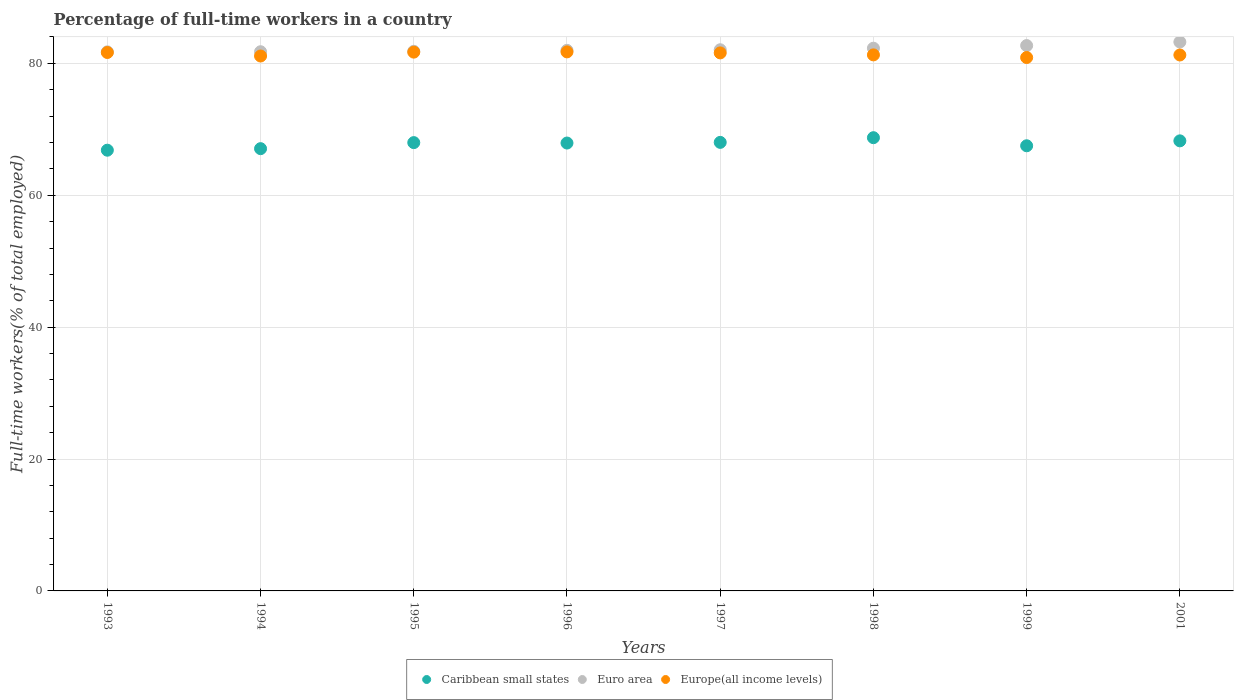What is the percentage of full-time workers in Europe(all income levels) in 2001?
Provide a succinct answer. 81.27. Across all years, what is the maximum percentage of full-time workers in Caribbean small states?
Offer a terse response. 68.73. Across all years, what is the minimum percentage of full-time workers in Europe(all income levels)?
Keep it short and to the point. 80.89. In which year was the percentage of full-time workers in Europe(all income levels) minimum?
Offer a very short reply. 1999. What is the total percentage of full-time workers in Caribbean small states in the graph?
Provide a succinct answer. 542.29. What is the difference between the percentage of full-time workers in Europe(all income levels) in 1996 and that in 2001?
Provide a succinct answer. 0.47. What is the difference between the percentage of full-time workers in Europe(all income levels) in 1998 and the percentage of full-time workers in Caribbean small states in 1994?
Your answer should be very brief. 14.22. What is the average percentage of full-time workers in Euro area per year?
Offer a very short reply. 82.2. In the year 1994, what is the difference between the percentage of full-time workers in Euro area and percentage of full-time workers in Caribbean small states?
Offer a terse response. 14.7. What is the ratio of the percentage of full-time workers in Europe(all income levels) in 1993 to that in 1994?
Make the answer very short. 1.01. Is the percentage of full-time workers in Euro area in 1997 less than that in 2001?
Keep it short and to the point. Yes. What is the difference between the highest and the second highest percentage of full-time workers in Caribbean small states?
Give a very brief answer. 0.48. What is the difference between the highest and the lowest percentage of full-time workers in Europe(all income levels)?
Ensure brevity in your answer.  0.85. In how many years, is the percentage of full-time workers in Euro area greater than the average percentage of full-time workers in Euro area taken over all years?
Your response must be concise. 3. Is it the case that in every year, the sum of the percentage of full-time workers in Caribbean small states and percentage of full-time workers in Euro area  is greater than the percentage of full-time workers in Europe(all income levels)?
Provide a succinct answer. Yes. Is the percentage of full-time workers in Caribbean small states strictly less than the percentage of full-time workers in Europe(all income levels) over the years?
Provide a succinct answer. Yes. How many dotlines are there?
Make the answer very short. 3. How many years are there in the graph?
Give a very brief answer. 8. Where does the legend appear in the graph?
Give a very brief answer. Bottom center. How many legend labels are there?
Ensure brevity in your answer.  3. How are the legend labels stacked?
Offer a very short reply. Horizontal. What is the title of the graph?
Your response must be concise. Percentage of full-time workers in a country. What is the label or title of the Y-axis?
Offer a very short reply. Full-time workers(% of total employed). What is the Full-time workers(% of total employed) of Caribbean small states in 1993?
Your answer should be very brief. 66.83. What is the Full-time workers(% of total employed) in Euro area in 1993?
Make the answer very short. 81.75. What is the Full-time workers(% of total employed) of Europe(all income levels) in 1993?
Provide a succinct answer. 81.65. What is the Full-time workers(% of total employed) in Caribbean small states in 1994?
Provide a succinct answer. 67.06. What is the Full-time workers(% of total employed) in Euro area in 1994?
Your answer should be compact. 81.76. What is the Full-time workers(% of total employed) of Europe(all income levels) in 1994?
Your answer should be compact. 81.12. What is the Full-time workers(% of total employed) of Caribbean small states in 1995?
Keep it short and to the point. 67.98. What is the Full-time workers(% of total employed) of Euro area in 1995?
Ensure brevity in your answer.  81.83. What is the Full-time workers(% of total employed) of Europe(all income levels) in 1995?
Your answer should be compact. 81.7. What is the Full-time workers(% of total employed) in Caribbean small states in 1996?
Give a very brief answer. 67.92. What is the Full-time workers(% of total employed) in Euro area in 1996?
Your answer should be compact. 81.98. What is the Full-time workers(% of total employed) of Europe(all income levels) in 1996?
Provide a succinct answer. 81.74. What is the Full-time workers(% of total employed) of Caribbean small states in 1997?
Your answer should be very brief. 68.02. What is the Full-time workers(% of total employed) in Euro area in 1997?
Offer a very short reply. 82.06. What is the Full-time workers(% of total employed) of Europe(all income levels) in 1997?
Provide a succinct answer. 81.59. What is the Full-time workers(% of total employed) of Caribbean small states in 1998?
Your response must be concise. 68.73. What is the Full-time workers(% of total employed) of Euro area in 1998?
Your answer should be very brief. 82.3. What is the Full-time workers(% of total employed) of Europe(all income levels) in 1998?
Your response must be concise. 81.29. What is the Full-time workers(% of total employed) in Caribbean small states in 1999?
Give a very brief answer. 67.5. What is the Full-time workers(% of total employed) of Euro area in 1999?
Offer a terse response. 82.7. What is the Full-time workers(% of total employed) of Europe(all income levels) in 1999?
Make the answer very short. 80.89. What is the Full-time workers(% of total employed) of Caribbean small states in 2001?
Provide a succinct answer. 68.25. What is the Full-time workers(% of total employed) in Euro area in 2001?
Provide a short and direct response. 83.24. What is the Full-time workers(% of total employed) of Europe(all income levels) in 2001?
Ensure brevity in your answer.  81.27. Across all years, what is the maximum Full-time workers(% of total employed) in Caribbean small states?
Offer a terse response. 68.73. Across all years, what is the maximum Full-time workers(% of total employed) of Euro area?
Your answer should be compact. 83.24. Across all years, what is the maximum Full-time workers(% of total employed) in Europe(all income levels)?
Provide a short and direct response. 81.74. Across all years, what is the minimum Full-time workers(% of total employed) in Caribbean small states?
Your response must be concise. 66.83. Across all years, what is the minimum Full-time workers(% of total employed) of Euro area?
Provide a succinct answer. 81.75. Across all years, what is the minimum Full-time workers(% of total employed) of Europe(all income levels)?
Keep it short and to the point. 80.89. What is the total Full-time workers(% of total employed) of Caribbean small states in the graph?
Keep it short and to the point. 542.29. What is the total Full-time workers(% of total employed) of Euro area in the graph?
Provide a short and direct response. 657.62. What is the total Full-time workers(% of total employed) in Europe(all income levels) in the graph?
Your answer should be compact. 651.23. What is the difference between the Full-time workers(% of total employed) in Caribbean small states in 1993 and that in 1994?
Make the answer very short. -0.23. What is the difference between the Full-time workers(% of total employed) in Euro area in 1993 and that in 1994?
Give a very brief answer. -0.02. What is the difference between the Full-time workers(% of total employed) of Europe(all income levels) in 1993 and that in 1994?
Offer a very short reply. 0.53. What is the difference between the Full-time workers(% of total employed) in Caribbean small states in 1993 and that in 1995?
Offer a very short reply. -1.15. What is the difference between the Full-time workers(% of total employed) of Euro area in 1993 and that in 1995?
Offer a very short reply. -0.08. What is the difference between the Full-time workers(% of total employed) of Europe(all income levels) in 1993 and that in 1995?
Give a very brief answer. -0.06. What is the difference between the Full-time workers(% of total employed) in Caribbean small states in 1993 and that in 1996?
Make the answer very short. -1.09. What is the difference between the Full-time workers(% of total employed) of Euro area in 1993 and that in 1996?
Provide a succinct answer. -0.23. What is the difference between the Full-time workers(% of total employed) in Europe(all income levels) in 1993 and that in 1996?
Make the answer very short. -0.09. What is the difference between the Full-time workers(% of total employed) in Caribbean small states in 1993 and that in 1997?
Provide a short and direct response. -1.19. What is the difference between the Full-time workers(% of total employed) of Euro area in 1993 and that in 1997?
Ensure brevity in your answer.  -0.32. What is the difference between the Full-time workers(% of total employed) of Europe(all income levels) in 1993 and that in 1997?
Your answer should be compact. 0.06. What is the difference between the Full-time workers(% of total employed) in Caribbean small states in 1993 and that in 1998?
Provide a short and direct response. -1.9. What is the difference between the Full-time workers(% of total employed) of Euro area in 1993 and that in 1998?
Offer a terse response. -0.55. What is the difference between the Full-time workers(% of total employed) in Europe(all income levels) in 1993 and that in 1998?
Your response must be concise. 0.36. What is the difference between the Full-time workers(% of total employed) in Caribbean small states in 1993 and that in 1999?
Give a very brief answer. -0.67. What is the difference between the Full-time workers(% of total employed) of Euro area in 1993 and that in 1999?
Offer a terse response. -0.95. What is the difference between the Full-time workers(% of total employed) of Europe(all income levels) in 1993 and that in 1999?
Your answer should be compact. 0.76. What is the difference between the Full-time workers(% of total employed) of Caribbean small states in 1993 and that in 2001?
Offer a terse response. -1.42. What is the difference between the Full-time workers(% of total employed) in Euro area in 1993 and that in 2001?
Your response must be concise. -1.49. What is the difference between the Full-time workers(% of total employed) of Europe(all income levels) in 1993 and that in 2001?
Make the answer very short. 0.37. What is the difference between the Full-time workers(% of total employed) in Caribbean small states in 1994 and that in 1995?
Your answer should be compact. -0.92. What is the difference between the Full-time workers(% of total employed) in Euro area in 1994 and that in 1995?
Provide a succinct answer. -0.07. What is the difference between the Full-time workers(% of total employed) in Europe(all income levels) in 1994 and that in 1995?
Make the answer very short. -0.59. What is the difference between the Full-time workers(% of total employed) of Caribbean small states in 1994 and that in 1996?
Your answer should be very brief. -0.85. What is the difference between the Full-time workers(% of total employed) in Euro area in 1994 and that in 1996?
Make the answer very short. -0.21. What is the difference between the Full-time workers(% of total employed) in Europe(all income levels) in 1994 and that in 1996?
Your response must be concise. -0.62. What is the difference between the Full-time workers(% of total employed) of Caribbean small states in 1994 and that in 1997?
Ensure brevity in your answer.  -0.95. What is the difference between the Full-time workers(% of total employed) in Euro area in 1994 and that in 1997?
Ensure brevity in your answer.  -0.3. What is the difference between the Full-time workers(% of total employed) in Europe(all income levels) in 1994 and that in 1997?
Give a very brief answer. -0.47. What is the difference between the Full-time workers(% of total employed) of Caribbean small states in 1994 and that in 1998?
Your answer should be very brief. -1.66. What is the difference between the Full-time workers(% of total employed) in Euro area in 1994 and that in 1998?
Your answer should be very brief. -0.54. What is the difference between the Full-time workers(% of total employed) of Europe(all income levels) in 1994 and that in 1998?
Provide a short and direct response. -0.17. What is the difference between the Full-time workers(% of total employed) in Caribbean small states in 1994 and that in 1999?
Offer a terse response. -0.44. What is the difference between the Full-time workers(% of total employed) in Euro area in 1994 and that in 1999?
Offer a terse response. -0.94. What is the difference between the Full-time workers(% of total employed) in Europe(all income levels) in 1994 and that in 1999?
Your answer should be very brief. 0.23. What is the difference between the Full-time workers(% of total employed) in Caribbean small states in 1994 and that in 2001?
Offer a very short reply. -1.18. What is the difference between the Full-time workers(% of total employed) in Euro area in 1994 and that in 2001?
Offer a very short reply. -1.48. What is the difference between the Full-time workers(% of total employed) of Europe(all income levels) in 1994 and that in 2001?
Offer a terse response. -0.16. What is the difference between the Full-time workers(% of total employed) in Caribbean small states in 1995 and that in 1996?
Offer a very short reply. 0.06. What is the difference between the Full-time workers(% of total employed) in Euro area in 1995 and that in 1996?
Give a very brief answer. -0.14. What is the difference between the Full-time workers(% of total employed) in Europe(all income levels) in 1995 and that in 1996?
Your answer should be compact. -0.04. What is the difference between the Full-time workers(% of total employed) in Caribbean small states in 1995 and that in 1997?
Provide a succinct answer. -0.04. What is the difference between the Full-time workers(% of total employed) of Euro area in 1995 and that in 1997?
Ensure brevity in your answer.  -0.23. What is the difference between the Full-time workers(% of total employed) of Europe(all income levels) in 1995 and that in 1997?
Provide a succinct answer. 0.11. What is the difference between the Full-time workers(% of total employed) of Caribbean small states in 1995 and that in 1998?
Make the answer very short. -0.75. What is the difference between the Full-time workers(% of total employed) in Euro area in 1995 and that in 1998?
Your answer should be very brief. -0.47. What is the difference between the Full-time workers(% of total employed) of Europe(all income levels) in 1995 and that in 1998?
Your answer should be very brief. 0.42. What is the difference between the Full-time workers(% of total employed) in Caribbean small states in 1995 and that in 1999?
Provide a succinct answer. 0.48. What is the difference between the Full-time workers(% of total employed) of Euro area in 1995 and that in 1999?
Ensure brevity in your answer.  -0.87. What is the difference between the Full-time workers(% of total employed) in Europe(all income levels) in 1995 and that in 1999?
Your answer should be compact. 0.82. What is the difference between the Full-time workers(% of total employed) in Caribbean small states in 1995 and that in 2001?
Ensure brevity in your answer.  -0.27. What is the difference between the Full-time workers(% of total employed) in Euro area in 1995 and that in 2001?
Provide a short and direct response. -1.41. What is the difference between the Full-time workers(% of total employed) of Europe(all income levels) in 1995 and that in 2001?
Offer a very short reply. 0.43. What is the difference between the Full-time workers(% of total employed) of Caribbean small states in 1996 and that in 1997?
Offer a terse response. -0.1. What is the difference between the Full-time workers(% of total employed) of Euro area in 1996 and that in 1997?
Offer a terse response. -0.09. What is the difference between the Full-time workers(% of total employed) of Europe(all income levels) in 1996 and that in 1997?
Ensure brevity in your answer.  0.15. What is the difference between the Full-time workers(% of total employed) in Caribbean small states in 1996 and that in 1998?
Your answer should be very brief. -0.81. What is the difference between the Full-time workers(% of total employed) of Euro area in 1996 and that in 1998?
Your answer should be very brief. -0.32. What is the difference between the Full-time workers(% of total employed) in Europe(all income levels) in 1996 and that in 1998?
Provide a short and direct response. 0.45. What is the difference between the Full-time workers(% of total employed) in Caribbean small states in 1996 and that in 1999?
Make the answer very short. 0.41. What is the difference between the Full-time workers(% of total employed) in Euro area in 1996 and that in 1999?
Keep it short and to the point. -0.72. What is the difference between the Full-time workers(% of total employed) in Europe(all income levels) in 1996 and that in 1999?
Keep it short and to the point. 0.85. What is the difference between the Full-time workers(% of total employed) in Caribbean small states in 1996 and that in 2001?
Your answer should be compact. -0.33. What is the difference between the Full-time workers(% of total employed) in Euro area in 1996 and that in 2001?
Offer a very short reply. -1.27. What is the difference between the Full-time workers(% of total employed) of Europe(all income levels) in 1996 and that in 2001?
Provide a succinct answer. 0.47. What is the difference between the Full-time workers(% of total employed) in Caribbean small states in 1997 and that in 1998?
Your answer should be compact. -0.71. What is the difference between the Full-time workers(% of total employed) in Euro area in 1997 and that in 1998?
Provide a short and direct response. -0.23. What is the difference between the Full-time workers(% of total employed) of Europe(all income levels) in 1997 and that in 1998?
Your answer should be very brief. 0.3. What is the difference between the Full-time workers(% of total employed) in Caribbean small states in 1997 and that in 1999?
Your response must be concise. 0.52. What is the difference between the Full-time workers(% of total employed) in Euro area in 1997 and that in 1999?
Your response must be concise. -0.63. What is the difference between the Full-time workers(% of total employed) in Europe(all income levels) in 1997 and that in 1999?
Provide a short and direct response. 0.7. What is the difference between the Full-time workers(% of total employed) in Caribbean small states in 1997 and that in 2001?
Provide a succinct answer. -0.23. What is the difference between the Full-time workers(% of total employed) in Euro area in 1997 and that in 2001?
Your response must be concise. -1.18. What is the difference between the Full-time workers(% of total employed) of Europe(all income levels) in 1997 and that in 2001?
Make the answer very short. 0.31. What is the difference between the Full-time workers(% of total employed) in Caribbean small states in 1998 and that in 1999?
Provide a short and direct response. 1.23. What is the difference between the Full-time workers(% of total employed) in Euro area in 1998 and that in 1999?
Your answer should be compact. -0.4. What is the difference between the Full-time workers(% of total employed) of Europe(all income levels) in 1998 and that in 1999?
Provide a succinct answer. 0.4. What is the difference between the Full-time workers(% of total employed) of Caribbean small states in 1998 and that in 2001?
Your answer should be very brief. 0.48. What is the difference between the Full-time workers(% of total employed) of Euro area in 1998 and that in 2001?
Keep it short and to the point. -0.94. What is the difference between the Full-time workers(% of total employed) of Europe(all income levels) in 1998 and that in 2001?
Keep it short and to the point. 0.01. What is the difference between the Full-time workers(% of total employed) in Caribbean small states in 1999 and that in 2001?
Offer a terse response. -0.75. What is the difference between the Full-time workers(% of total employed) of Euro area in 1999 and that in 2001?
Your answer should be compact. -0.54. What is the difference between the Full-time workers(% of total employed) in Europe(all income levels) in 1999 and that in 2001?
Provide a short and direct response. -0.39. What is the difference between the Full-time workers(% of total employed) in Caribbean small states in 1993 and the Full-time workers(% of total employed) in Euro area in 1994?
Offer a very short reply. -14.93. What is the difference between the Full-time workers(% of total employed) of Caribbean small states in 1993 and the Full-time workers(% of total employed) of Europe(all income levels) in 1994?
Provide a succinct answer. -14.28. What is the difference between the Full-time workers(% of total employed) in Euro area in 1993 and the Full-time workers(% of total employed) in Europe(all income levels) in 1994?
Provide a short and direct response. 0.63. What is the difference between the Full-time workers(% of total employed) of Caribbean small states in 1993 and the Full-time workers(% of total employed) of Euro area in 1995?
Give a very brief answer. -15. What is the difference between the Full-time workers(% of total employed) in Caribbean small states in 1993 and the Full-time workers(% of total employed) in Europe(all income levels) in 1995?
Ensure brevity in your answer.  -14.87. What is the difference between the Full-time workers(% of total employed) of Euro area in 1993 and the Full-time workers(% of total employed) of Europe(all income levels) in 1995?
Your answer should be very brief. 0.05. What is the difference between the Full-time workers(% of total employed) of Caribbean small states in 1993 and the Full-time workers(% of total employed) of Euro area in 1996?
Your response must be concise. -15.14. What is the difference between the Full-time workers(% of total employed) in Caribbean small states in 1993 and the Full-time workers(% of total employed) in Europe(all income levels) in 1996?
Ensure brevity in your answer.  -14.91. What is the difference between the Full-time workers(% of total employed) in Euro area in 1993 and the Full-time workers(% of total employed) in Europe(all income levels) in 1996?
Keep it short and to the point. 0.01. What is the difference between the Full-time workers(% of total employed) in Caribbean small states in 1993 and the Full-time workers(% of total employed) in Euro area in 1997?
Offer a very short reply. -15.23. What is the difference between the Full-time workers(% of total employed) of Caribbean small states in 1993 and the Full-time workers(% of total employed) of Europe(all income levels) in 1997?
Give a very brief answer. -14.76. What is the difference between the Full-time workers(% of total employed) in Euro area in 1993 and the Full-time workers(% of total employed) in Europe(all income levels) in 1997?
Give a very brief answer. 0.16. What is the difference between the Full-time workers(% of total employed) of Caribbean small states in 1993 and the Full-time workers(% of total employed) of Euro area in 1998?
Your answer should be compact. -15.47. What is the difference between the Full-time workers(% of total employed) in Caribbean small states in 1993 and the Full-time workers(% of total employed) in Europe(all income levels) in 1998?
Your response must be concise. -14.45. What is the difference between the Full-time workers(% of total employed) in Euro area in 1993 and the Full-time workers(% of total employed) in Europe(all income levels) in 1998?
Offer a terse response. 0.46. What is the difference between the Full-time workers(% of total employed) of Caribbean small states in 1993 and the Full-time workers(% of total employed) of Euro area in 1999?
Make the answer very short. -15.87. What is the difference between the Full-time workers(% of total employed) in Caribbean small states in 1993 and the Full-time workers(% of total employed) in Europe(all income levels) in 1999?
Offer a terse response. -14.05. What is the difference between the Full-time workers(% of total employed) in Euro area in 1993 and the Full-time workers(% of total employed) in Europe(all income levels) in 1999?
Keep it short and to the point. 0.86. What is the difference between the Full-time workers(% of total employed) of Caribbean small states in 1993 and the Full-time workers(% of total employed) of Euro area in 2001?
Give a very brief answer. -16.41. What is the difference between the Full-time workers(% of total employed) in Caribbean small states in 1993 and the Full-time workers(% of total employed) in Europe(all income levels) in 2001?
Your response must be concise. -14.44. What is the difference between the Full-time workers(% of total employed) of Euro area in 1993 and the Full-time workers(% of total employed) of Europe(all income levels) in 2001?
Give a very brief answer. 0.47. What is the difference between the Full-time workers(% of total employed) of Caribbean small states in 1994 and the Full-time workers(% of total employed) of Euro area in 1995?
Keep it short and to the point. -14.77. What is the difference between the Full-time workers(% of total employed) in Caribbean small states in 1994 and the Full-time workers(% of total employed) in Europe(all income levels) in 1995?
Offer a terse response. -14.64. What is the difference between the Full-time workers(% of total employed) in Euro area in 1994 and the Full-time workers(% of total employed) in Europe(all income levels) in 1995?
Provide a succinct answer. 0.06. What is the difference between the Full-time workers(% of total employed) of Caribbean small states in 1994 and the Full-time workers(% of total employed) of Euro area in 1996?
Provide a short and direct response. -14.91. What is the difference between the Full-time workers(% of total employed) of Caribbean small states in 1994 and the Full-time workers(% of total employed) of Europe(all income levels) in 1996?
Offer a terse response. -14.67. What is the difference between the Full-time workers(% of total employed) in Euro area in 1994 and the Full-time workers(% of total employed) in Europe(all income levels) in 1996?
Keep it short and to the point. 0.02. What is the difference between the Full-time workers(% of total employed) of Caribbean small states in 1994 and the Full-time workers(% of total employed) of Euro area in 1997?
Offer a terse response. -15. What is the difference between the Full-time workers(% of total employed) in Caribbean small states in 1994 and the Full-time workers(% of total employed) in Europe(all income levels) in 1997?
Give a very brief answer. -14.52. What is the difference between the Full-time workers(% of total employed) of Euro area in 1994 and the Full-time workers(% of total employed) of Europe(all income levels) in 1997?
Provide a succinct answer. 0.18. What is the difference between the Full-time workers(% of total employed) of Caribbean small states in 1994 and the Full-time workers(% of total employed) of Euro area in 1998?
Provide a short and direct response. -15.23. What is the difference between the Full-time workers(% of total employed) of Caribbean small states in 1994 and the Full-time workers(% of total employed) of Europe(all income levels) in 1998?
Your response must be concise. -14.22. What is the difference between the Full-time workers(% of total employed) of Euro area in 1994 and the Full-time workers(% of total employed) of Europe(all income levels) in 1998?
Keep it short and to the point. 0.48. What is the difference between the Full-time workers(% of total employed) in Caribbean small states in 1994 and the Full-time workers(% of total employed) in Euro area in 1999?
Your response must be concise. -15.63. What is the difference between the Full-time workers(% of total employed) of Caribbean small states in 1994 and the Full-time workers(% of total employed) of Europe(all income levels) in 1999?
Provide a short and direct response. -13.82. What is the difference between the Full-time workers(% of total employed) of Euro area in 1994 and the Full-time workers(% of total employed) of Europe(all income levels) in 1999?
Ensure brevity in your answer.  0.88. What is the difference between the Full-time workers(% of total employed) of Caribbean small states in 1994 and the Full-time workers(% of total employed) of Euro area in 2001?
Provide a succinct answer. -16.18. What is the difference between the Full-time workers(% of total employed) in Caribbean small states in 1994 and the Full-time workers(% of total employed) in Europe(all income levels) in 2001?
Offer a very short reply. -14.21. What is the difference between the Full-time workers(% of total employed) of Euro area in 1994 and the Full-time workers(% of total employed) of Europe(all income levels) in 2001?
Offer a terse response. 0.49. What is the difference between the Full-time workers(% of total employed) in Caribbean small states in 1995 and the Full-time workers(% of total employed) in Euro area in 1996?
Give a very brief answer. -13.99. What is the difference between the Full-time workers(% of total employed) in Caribbean small states in 1995 and the Full-time workers(% of total employed) in Europe(all income levels) in 1996?
Make the answer very short. -13.76. What is the difference between the Full-time workers(% of total employed) in Euro area in 1995 and the Full-time workers(% of total employed) in Europe(all income levels) in 1996?
Your response must be concise. 0.09. What is the difference between the Full-time workers(% of total employed) of Caribbean small states in 1995 and the Full-time workers(% of total employed) of Euro area in 1997?
Ensure brevity in your answer.  -14.08. What is the difference between the Full-time workers(% of total employed) in Caribbean small states in 1995 and the Full-time workers(% of total employed) in Europe(all income levels) in 1997?
Provide a short and direct response. -13.61. What is the difference between the Full-time workers(% of total employed) of Euro area in 1995 and the Full-time workers(% of total employed) of Europe(all income levels) in 1997?
Give a very brief answer. 0.24. What is the difference between the Full-time workers(% of total employed) of Caribbean small states in 1995 and the Full-time workers(% of total employed) of Euro area in 1998?
Provide a succinct answer. -14.32. What is the difference between the Full-time workers(% of total employed) in Caribbean small states in 1995 and the Full-time workers(% of total employed) in Europe(all income levels) in 1998?
Offer a terse response. -13.3. What is the difference between the Full-time workers(% of total employed) in Euro area in 1995 and the Full-time workers(% of total employed) in Europe(all income levels) in 1998?
Your response must be concise. 0.55. What is the difference between the Full-time workers(% of total employed) of Caribbean small states in 1995 and the Full-time workers(% of total employed) of Euro area in 1999?
Your response must be concise. -14.72. What is the difference between the Full-time workers(% of total employed) of Caribbean small states in 1995 and the Full-time workers(% of total employed) of Europe(all income levels) in 1999?
Ensure brevity in your answer.  -12.9. What is the difference between the Full-time workers(% of total employed) in Euro area in 1995 and the Full-time workers(% of total employed) in Europe(all income levels) in 1999?
Make the answer very short. 0.94. What is the difference between the Full-time workers(% of total employed) of Caribbean small states in 1995 and the Full-time workers(% of total employed) of Euro area in 2001?
Give a very brief answer. -15.26. What is the difference between the Full-time workers(% of total employed) in Caribbean small states in 1995 and the Full-time workers(% of total employed) in Europe(all income levels) in 2001?
Ensure brevity in your answer.  -13.29. What is the difference between the Full-time workers(% of total employed) in Euro area in 1995 and the Full-time workers(% of total employed) in Europe(all income levels) in 2001?
Provide a short and direct response. 0.56. What is the difference between the Full-time workers(% of total employed) in Caribbean small states in 1996 and the Full-time workers(% of total employed) in Euro area in 1997?
Offer a terse response. -14.15. What is the difference between the Full-time workers(% of total employed) in Caribbean small states in 1996 and the Full-time workers(% of total employed) in Europe(all income levels) in 1997?
Your answer should be compact. -13.67. What is the difference between the Full-time workers(% of total employed) of Euro area in 1996 and the Full-time workers(% of total employed) of Europe(all income levels) in 1997?
Ensure brevity in your answer.  0.39. What is the difference between the Full-time workers(% of total employed) in Caribbean small states in 1996 and the Full-time workers(% of total employed) in Euro area in 1998?
Ensure brevity in your answer.  -14.38. What is the difference between the Full-time workers(% of total employed) in Caribbean small states in 1996 and the Full-time workers(% of total employed) in Europe(all income levels) in 1998?
Your answer should be compact. -13.37. What is the difference between the Full-time workers(% of total employed) in Euro area in 1996 and the Full-time workers(% of total employed) in Europe(all income levels) in 1998?
Offer a terse response. 0.69. What is the difference between the Full-time workers(% of total employed) in Caribbean small states in 1996 and the Full-time workers(% of total employed) in Euro area in 1999?
Keep it short and to the point. -14.78. What is the difference between the Full-time workers(% of total employed) in Caribbean small states in 1996 and the Full-time workers(% of total employed) in Europe(all income levels) in 1999?
Provide a short and direct response. -12.97. What is the difference between the Full-time workers(% of total employed) of Euro area in 1996 and the Full-time workers(% of total employed) of Europe(all income levels) in 1999?
Make the answer very short. 1.09. What is the difference between the Full-time workers(% of total employed) in Caribbean small states in 1996 and the Full-time workers(% of total employed) in Euro area in 2001?
Your answer should be very brief. -15.32. What is the difference between the Full-time workers(% of total employed) of Caribbean small states in 1996 and the Full-time workers(% of total employed) of Europe(all income levels) in 2001?
Offer a terse response. -13.35. What is the difference between the Full-time workers(% of total employed) in Euro area in 1996 and the Full-time workers(% of total employed) in Europe(all income levels) in 2001?
Your answer should be very brief. 0.7. What is the difference between the Full-time workers(% of total employed) of Caribbean small states in 1997 and the Full-time workers(% of total employed) of Euro area in 1998?
Your answer should be compact. -14.28. What is the difference between the Full-time workers(% of total employed) in Caribbean small states in 1997 and the Full-time workers(% of total employed) in Europe(all income levels) in 1998?
Provide a succinct answer. -13.27. What is the difference between the Full-time workers(% of total employed) of Euro area in 1997 and the Full-time workers(% of total employed) of Europe(all income levels) in 1998?
Your answer should be compact. 0.78. What is the difference between the Full-time workers(% of total employed) of Caribbean small states in 1997 and the Full-time workers(% of total employed) of Euro area in 1999?
Your answer should be very brief. -14.68. What is the difference between the Full-time workers(% of total employed) of Caribbean small states in 1997 and the Full-time workers(% of total employed) of Europe(all income levels) in 1999?
Make the answer very short. -12.87. What is the difference between the Full-time workers(% of total employed) in Euro area in 1997 and the Full-time workers(% of total employed) in Europe(all income levels) in 1999?
Keep it short and to the point. 1.18. What is the difference between the Full-time workers(% of total employed) of Caribbean small states in 1997 and the Full-time workers(% of total employed) of Euro area in 2001?
Your response must be concise. -15.22. What is the difference between the Full-time workers(% of total employed) of Caribbean small states in 1997 and the Full-time workers(% of total employed) of Europe(all income levels) in 2001?
Provide a short and direct response. -13.25. What is the difference between the Full-time workers(% of total employed) in Euro area in 1997 and the Full-time workers(% of total employed) in Europe(all income levels) in 2001?
Your response must be concise. 0.79. What is the difference between the Full-time workers(% of total employed) in Caribbean small states in 1998 and the Full-time workers(% of total employed) in Euro area in 1999?
Provide a succinct answer. -13.97. What is the difference between the Full-time workers(% of total employed) in Caribbean small states in 1998 and the Full-time workers(% of total employed) in Europe(all income levels) in 1999?
Provide a short and direct response. -12.16. What is the difference between the Full-time workers(% of total employed) in Euro area in 1998 and the Full-time workers(% of total employed) in Europe(all income levels) in 1999?
Offer a very short reply. 1.41. What is the difference between the Full-time workers(% of total employed) in Caribbean small states in 1998 and the Full-time workers(% of total employed) in Euro area in 2001?
Offer a very short reply. -14.51. What is the difference between the Full-time workers(% of total employed) of Caribbean small states in 1998 and the Full-time workers(% of total employed) of Europe(all income levels) in 2001?
Offer a terse response. -12.54. What is the difference between the Full-time workers(% of total employed) in Euro area in 1998 and the Full-time workers(% of total employed) in Europe(all income levels) in 2001?
Make the answer very short. 1.03. What is the difference between the Full-time workers(% of total employed) of Caribbean small states in 1999 and the Full-time workers(% of total employed) of Euro area in 2001?
Offer a very short reply. -15.74. What is the difference between the Full-time workers(% of total employed) in Caribbean small states in 1999 and the Full-time workers(% of total employed) in Europe(all income levels) in 2001?
Your answer should be compact. -13.77. What is the difference between the Full-time workers(% of total employed) in Euro area in 1999 and the Full-time workers(% of total employed) in Europe(all income levels) in 2001?
Your answer should be very brief. 1.43. What is the average Full-time workers(% of total employed) in Caribbean small states per year?
Give a very brief answer. 67.79. What is the average Full-time workers(% of total employed) in Euro area per year?
Your response must be concise. 82.2. What is the average Full-time workers(% of total employed) of Europe(all income levels) per year?
Ensure brevity in your answer.  81.4. In the year 1993, what is the difference between the Full-time workers(% of total employed) in Caribbean small states and Full-time workers(% of total employed) in Euro area?
Provide a short and direct response. -14.91. In the year 1993, what is the difference between the Full-time workers(% of total employed) in Caribbean small states and Full-time workers(% of total employed) in Europe(all income levels)?
Provide a succinct answer. -14.81. In the year 1993, what is the difference between the Full-time workers(% of total employed) of Euro area and Full-time workers(% of total employed) of Europe(all income levels)?
Offer a very short reply. 0.1. In the year 1994, what is the difference between the Full-time workers(% of total employed) of Caribbean small states and Full-time workers(% of total employed) of Euro area?
Your answer should be compact. -14.7. In the year 1994, what is the difference between the Full-time workers(% of total employed) of Caribbean small states and Full-time workers(% of total employed) of Europe(all income levels)?
Provide a short and direct response. -14.05. In the year 1994, what is the difference between the Full-time workers(% of total employed) in Euro area and Full-time workers(% of total employed) in Europe(all income levels)?
Your answer should be compact. 0.65. In the year 1995, what is the difference between the Full-time workers(% of total employed) of Caribbean small states and Full-time workers(% of total employed) of Euro area?
Give a very brief answer. -13.85. In the year 1995, what is the difference between the Full-time workers(% of total employed) in Caribbean small states and Full-time workers(% of total employed) in Europe(all income levels)?
Provide a succinct answer. -13.72. In the year 1995, what is the difference between the Full-time workers(% of total employed) in Euro area and Full-time workers(% of total employed) in Europe(all income levels)?
Make the answer very short. 0.13. In the year 1996, what is the difference between the Full-time workers(% of total employed) in Caribbean small states and Full-time workers(% of total employed) in Euro area?
Make the answer very short. -14.06. In the year 1996, what is the difference between the Full-time workers(% of total employed) in Caribbean small states and Full-time workers(% of total employed) in Europe(all income levels)?
Keep it short and to the point. -13.82. In the year 1996, what is the difference between the Full-time workers(% of total employed) of Euro area and Full-time workers(% of total employed) of Europe(all income levels)?
Your answer should be compact. 0.24. In the year 1997, what is the difference between the Full-time workers(% of total employed) of Caribbean small states and Full-time workers(% of total employed) of Euro area?
Keep it short and to the point. -14.05. In the year 1997, what is the difference between the Full-time workers(% of total employed) in Caribbean small states and Full-time workers(% of total employed) in Europe(all income levels)?
Make the answer very short. -13.57. In the year 1997, what is the difference between the Full-time workers(% of total employed) of Euro area and Full-time workers(% of total employed) of Europe(all income levels)?
Provide a short and direct response. 0.48. In the year 1998, what is the difference between the Full-time workers(% of total employed) of Caribbean small states and Full-time workers(% of total employed) of Euro area?
Your answer should be very brief. -13.57. In the year 1998, what is the difference between the Full-time workers(% of total employed) of Caribbean small states and Full-time workers(% of total employed) of Europe(all income levels)?
Keep it short and to the point. -12.56. In the year 1998, what is the difference between the Full-time workers(% of total employed) in Euro area and Full-time workers(% of total employed) in Europe(all income levels)?
Your response must be concise. 1.01. In the year 1999, what is the difference between the Full-time workers(% of total employed) of Caribbean small states and Full-time workers(% of total employed) of Euro area?
Give a very brief answer. -15.2. In the year 1999, what is the difference between the Full-time workers(% of total employed) in Caribbean small states and Full-time workers(% of total employed) in Europe(all income levels)?
Ensure brevity in your answer.  -13.38. In the year 1999, what is the difference between the Full-time workers(% of total employed) in Euro area and Full-time workers(% of total employed) in Europe(all income levels)?
Your answer should be compact. 1.81. In the year 2001, what is the difference between the Full-time workers(% of total employed) in Caribbean small states and Full-time workers(% of total employed) in Euro area?
Your answer should be compact. -14.99. In the year 2001, what is the difference between the Full-time workers(% of total employed) in Caribbean small states and Full-time workers(% of total employed) in Europe(all income levels)?
Your answer should be very brief. -13.02. In the year 2001, what is the difference between the Full-time workers(% of total employed) of Euro area and Full-time workers(% of total employed) of Europe(all income levels)?
Your response must be concise. 1.97. What is the ratio of the Full-time workers(% of total employed) of Caribbean small states in 1993 to that in 1994?
Provide a succinct answer. 1. What is the ratio of the Full-time workers(% of total employed) in Europe(all income levels) in 1993 to that in 1994?
Make the answer very short. 1.01. What is the ratio of the Full-time workers(% of total employed) of Caribbean small states in 1993 to that in 1995?
Give a very brief answer. 0.98. What is the ratio of the Full-time workers(% of total employed) of Euro area in 1993 to that in 1996?
Your answer should be compact. 1. What is the ratio of the Full-time workers(% of total employed) in Europe(all income levels) in 1993 to that in 1996?
Provide a short and direct response. 1. What is the ratio of the Full-time workers(% of total employed) in Caribbean small states in 1993 to that in 1997?
Offer a very short reply. 0.98. What is the ratio of the Full-time workers(% of total employed) in Caribbean small states in 1993 to that in 1998?
Your answer should be compact. 0.97. What is the ratio of the Full-time workers(% of total employed) of Europe(all income levels) in 1993 to that in 1999?
Keep it short and to the point. 1.01. What is the ratio of the Full-time workers(% of total employed) of Caribbean small states in 1993 to that in 2001?
Your answer should be compact. 0.98. What is the ratio of the Full-time workers(% of total employed) in Europe(all income levels) in 1993 to that in 2001?
Offer a terse response. 1. What is the ratio of the Full-time workers(% of total employed) in Caribbean small states in 1994 to that in 1995?
Offer a very short reply. 0.99. What is the ratio of the Full-time workers(% of total employed) in Caribbean small states in 1994 to that in 1996?
Give a very brief answer. 0.99. What is the ratio of the Full-time workers(% of total employed) of Europe(all income levels) in 1994 to that in 1996?
Your response must be concise. 0.99. What is the ratio of the Full-time workers(% of total employed) in Caribbean small states in 1994 to that in 1998?
Your answer should be very brief. 0.98. What is the ratio of the Full-time workers(% of total employed) of Euro area in 1994 to that in 1998?
Your response must be concise. 0.99. What is the ratio of the Full-time workers(% of total employed) in Caribbean small states in 1994 to that in 1999?
Offer a very short reply. 0.99. What is the ratio of the Full-time workers(% of total employed) of Euro area in 1994 to that in 1999?
Give a very brief answer. 0.99. What is the ratio of the Full-time workers(% of total employed) of Caribbean small states in 1994 to that in 2001?
Provide a short and direct response. 0.98. What is the ratio of the Full-time workers(% of total employed) in Euro area in 1994 to that in 2001?
Provide a short and direct response. 0.98. What is the ratio of the Full-time workers(% of total employed) of Caribbean small states in 1995 to that in 1997?
Give a very brief answer. 1. What is the ratio of the Full-time workers(% of total employed) of Europe(all income levels) in 1995 to that in 1997?
Your answer should be very brief. 1. What is the ratio of the Full-time workers(% of total employed) of Caribbean small states in 1995 to that in 1998?
Your answer should be compact. 0.99. What is the ratio of the Full-time workers(% of total employed) of Europe(all income levels) in 1995 to that in 1998?
Provide a succinct answer. 1.01. What is the ratio of the Full-time workers(% of total employed) of Caribbean small states in 1995 to that in 1999?
Make the answer very short. 1.01. What is the ratio of the Full-time workers(% of total employed) in Euro area in 1995 to that in 1999?
Your answer should be very brief. 0.99. What is the ratio of the Full-time workers(% of total employed) in Europe(all income levels) in 1995 to that in 1999?
Provide a succinct answer. 1.01. What is the ratio of the Full-time workers(% of total employed) of Euro area in 1995 to that in 2001?
Offer a terse response. 0.98. What is the ratio of the Full-time workers(% of total employed) of Caribbean small states in 1996 to that in 1997?
Your answer should be compact. 1. What is the ratio of the Full-time workers(% of total employed) in Euro area in 1996 to that in 1997?
Offer a terse response. 1. What is the ratio of the Full-time workers(% of total employed) in Caribbean small states in 1996 to that in 1998?
Your response must be concise. 0.99. What is the ratio of the Full-time workers(% of total employed) in Euro area in 1996 to that in 1998?
Your answer should be very brief. 1. What is the ratio of the Full-time workers(% of total employed) in Europe(all income levels) in 1996 to that in 1998?
Your answer should be very brief. 1.01. What is the ratio of the Full-time workers(% of total employed) of Caribbean small states in 1996 to that in 1999?
Your response must be concise. 1.01. What is the ratio of the Full-time workers(% of total employed) of Euro area in 1996 to that in 1999?
Your answer should be compact. 0.99. What is the ratio of the Full-time workers(% of total employed) in Europe(all income levels) in 1996 to that in 1999?
Offer a very short reply. 1.01. What is the ratio of the Full-time workers(% of total employed) in Euro area in 1996 to that in 2001?
Give a very brief answer. 0.98. What is the ratio of the Full-time workers(% of total employed) of Europe(all income levels) in 1996 to that in 2001?
Give a very brief answer. 1.01. What is the ratio of the Full-time workers(% of total employed) of Caribbean small states in 1997 to that in 1998?
Ensure brevity in your answer.  0.99. What is the ratio of the Full-time workers(% of total employed) of Europe(all income levels) in 1997 to that in 1998?
Offer a very short reply. 1. What is the ratio of the Full-time workers(% of total employed) of Caribbean small states in 1997 to that in 1999?
Give a very brief answer. 1.01. What is the ratio of the Full-time workers(% of total employed) in Europe(all income levels) in 1997 to that in 1999?
Provide a succinct answer. 1.01. What is the ratio of the Full-time workers(% of total employed) in Euro area in 1997 to that in 2001?
Offer a very short reply. 0.99. What is the ratio of the Full-time workers(% of total employed) of Europe(all income levels) in 1997 to that in 2001?
Keep it short and to the point. 1. What is the ratio of the Full-time workers(% of total employed) in Caribbean small states in 1998 to that in 1999?
Provide a succinct answer. 1.02. What is the ratio of the Full-time workers(% of total employed) of Caribbean small states in 1998 to that in 2001?
Provide a succinct answer. 1.01. What is the ratio of the Full-time workers(% of total employed) in Euro area in 1998 to that in 2001?
Your answer should be very brief. 0.99. What is the ratio of the Full-time workers(% of total employed) of Caribbean small states in 1999 to that in 2001?
Provide a short and direct response. 0.99. What is the difference between the highest and the second highest Full-time workers(% of total employed) of Caribbean small states?
Offer a terse response. 0.48. What is the difference between the highest and the second highest Full-time workers(% of total employed) of Euro area?
Offer a very short reply. 0.54. What is the difference between the highest and the second highest Full-time workers(% of total employed) in Europe(all income levels)?
Offer a very short reply. 0.04. What is the difference between the highest and the lowest Full-time workers(% of total employed) of Caribbean small states?
Your response must be concise. 1.9. What is the difference between the highest and the lowest Full-time workers(% of total employed) of Euro area?
Provide a short and direct response. 1.49. What is the difference between the highest and the lowest Full-time workers(% of total employed) of Europe(all income levels)?
Offer a very short reply. 0.85. 